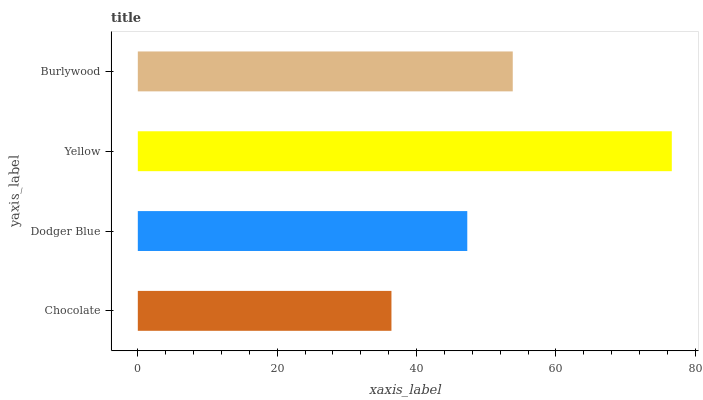Is Chocolate the minimum?
Answer yes or no. Yes. Is Yellow the maximum?
Answer yes or no. Yes. Is Dodger Blue the minimum?
Answer yes or no. No. Is Dodger Blue the maximum?
Answer yes or no. No. Is Dodger Blue greater than Chocolate?
Answer yes or no. Yes. Is Chocolate less than Dodger Blue?
Answer yes or no. Yes. Is Chocolate greater than Dodger Blue?
Answer yes or no. No. Is Dodger Blue less than Chocolate?
Answer yes or no. No. Is Burlywood the high median?
Answer yes or no. Yes. Is Dodger Blue the low median?
Answer yes or no. Yes. Is Yellow the high median?
Answer yes or no. No. Is Burlywood the low median?
Answer yes or no. No. 